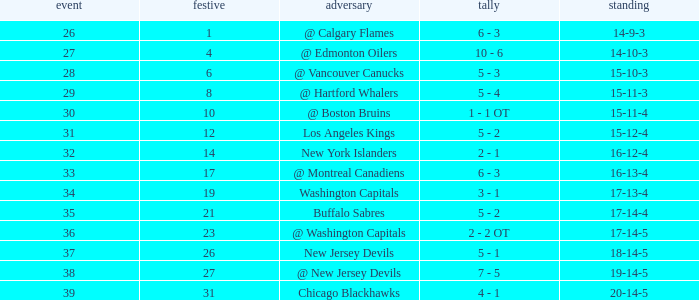Help me parse the entirety of this table. {'header': ['event', 'festive', 'adversary', 'tally', 'standing'], 'rows': [['26', '1', '@ Calgary Flames', '6 - 3', '14-9-3'], ['27', '4', '@ Edmonton Oilers', '10 - 6', '14-10-3'], ['28', '6', '@ Vancouver Canucks', '5 - 3', '15-10-3'], ['29', '8', '@ Hartford Whalers', '5 - 4', '15-11-3'], ['30', '10', '@ Boston Bruins', '1 - 1 OT', '15-11-4'], ['31', '12', 'Los Angeles Kings', '5 - 2', '15-12-4'], ['32', '14', 'New York Islanders', '2 - 1', '16-12-4'], ['33', '17', '@ Montreal Canadiens', '6 - 3', '16-13-4'], ['34', '19', 'Washington Capitals', '3 - 1', '17-13-4'], ['35', '21', 'Buffalo Sabres', '5 - 2', '17-14-4'], ['36', '23', '@ Washington Capitals', '2 - 2 OT', '17-14-5'], ['37', '26', 'New Jersey Devils', '5 - 1', '18-14-5'], ['38', '27', '@ New Jersey Devils', '7 - 5', '19-14-5'], ['39', '31', 'Chicago Blackhawks', '4 - 1', '20-14-5']]} Record of 15-12-4, and a Game larger than 31 involves what highest December? None. 